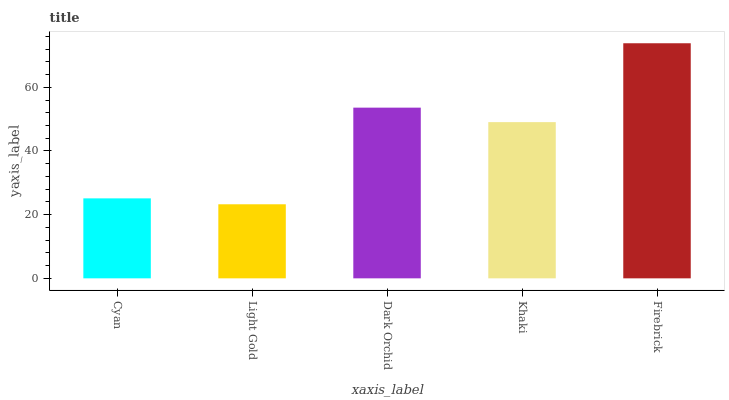Is Light Gold the minimum?
Answer yes or no. Yes. Is Firebrick the maximum?
Answer yes or no. Yes. Is Dark Orchid the minimum?
Answer yes or no. No. Is Dark Orchid the maximum?
Answer yes or no. No. Is Dark Orchid greater than Light Gold?
Answer yes or no. Yes. Is Light Gold less than Dark Orchid?
Answer yes or no. Yes. Is Light Gold greater than Dark Orchid?
Answer yes or no. No. Is Dark Orchid less than Light Gold?
Answer yes or no. No. Is Khaki the high median?
Answer yes or no. Yes. Is Khaki the low median?
Answer yes or no. Yes. Is Dark Orchid the high median?
Answer yes or no. No. Is Cyan the low median?
Answer yes or no. No. 